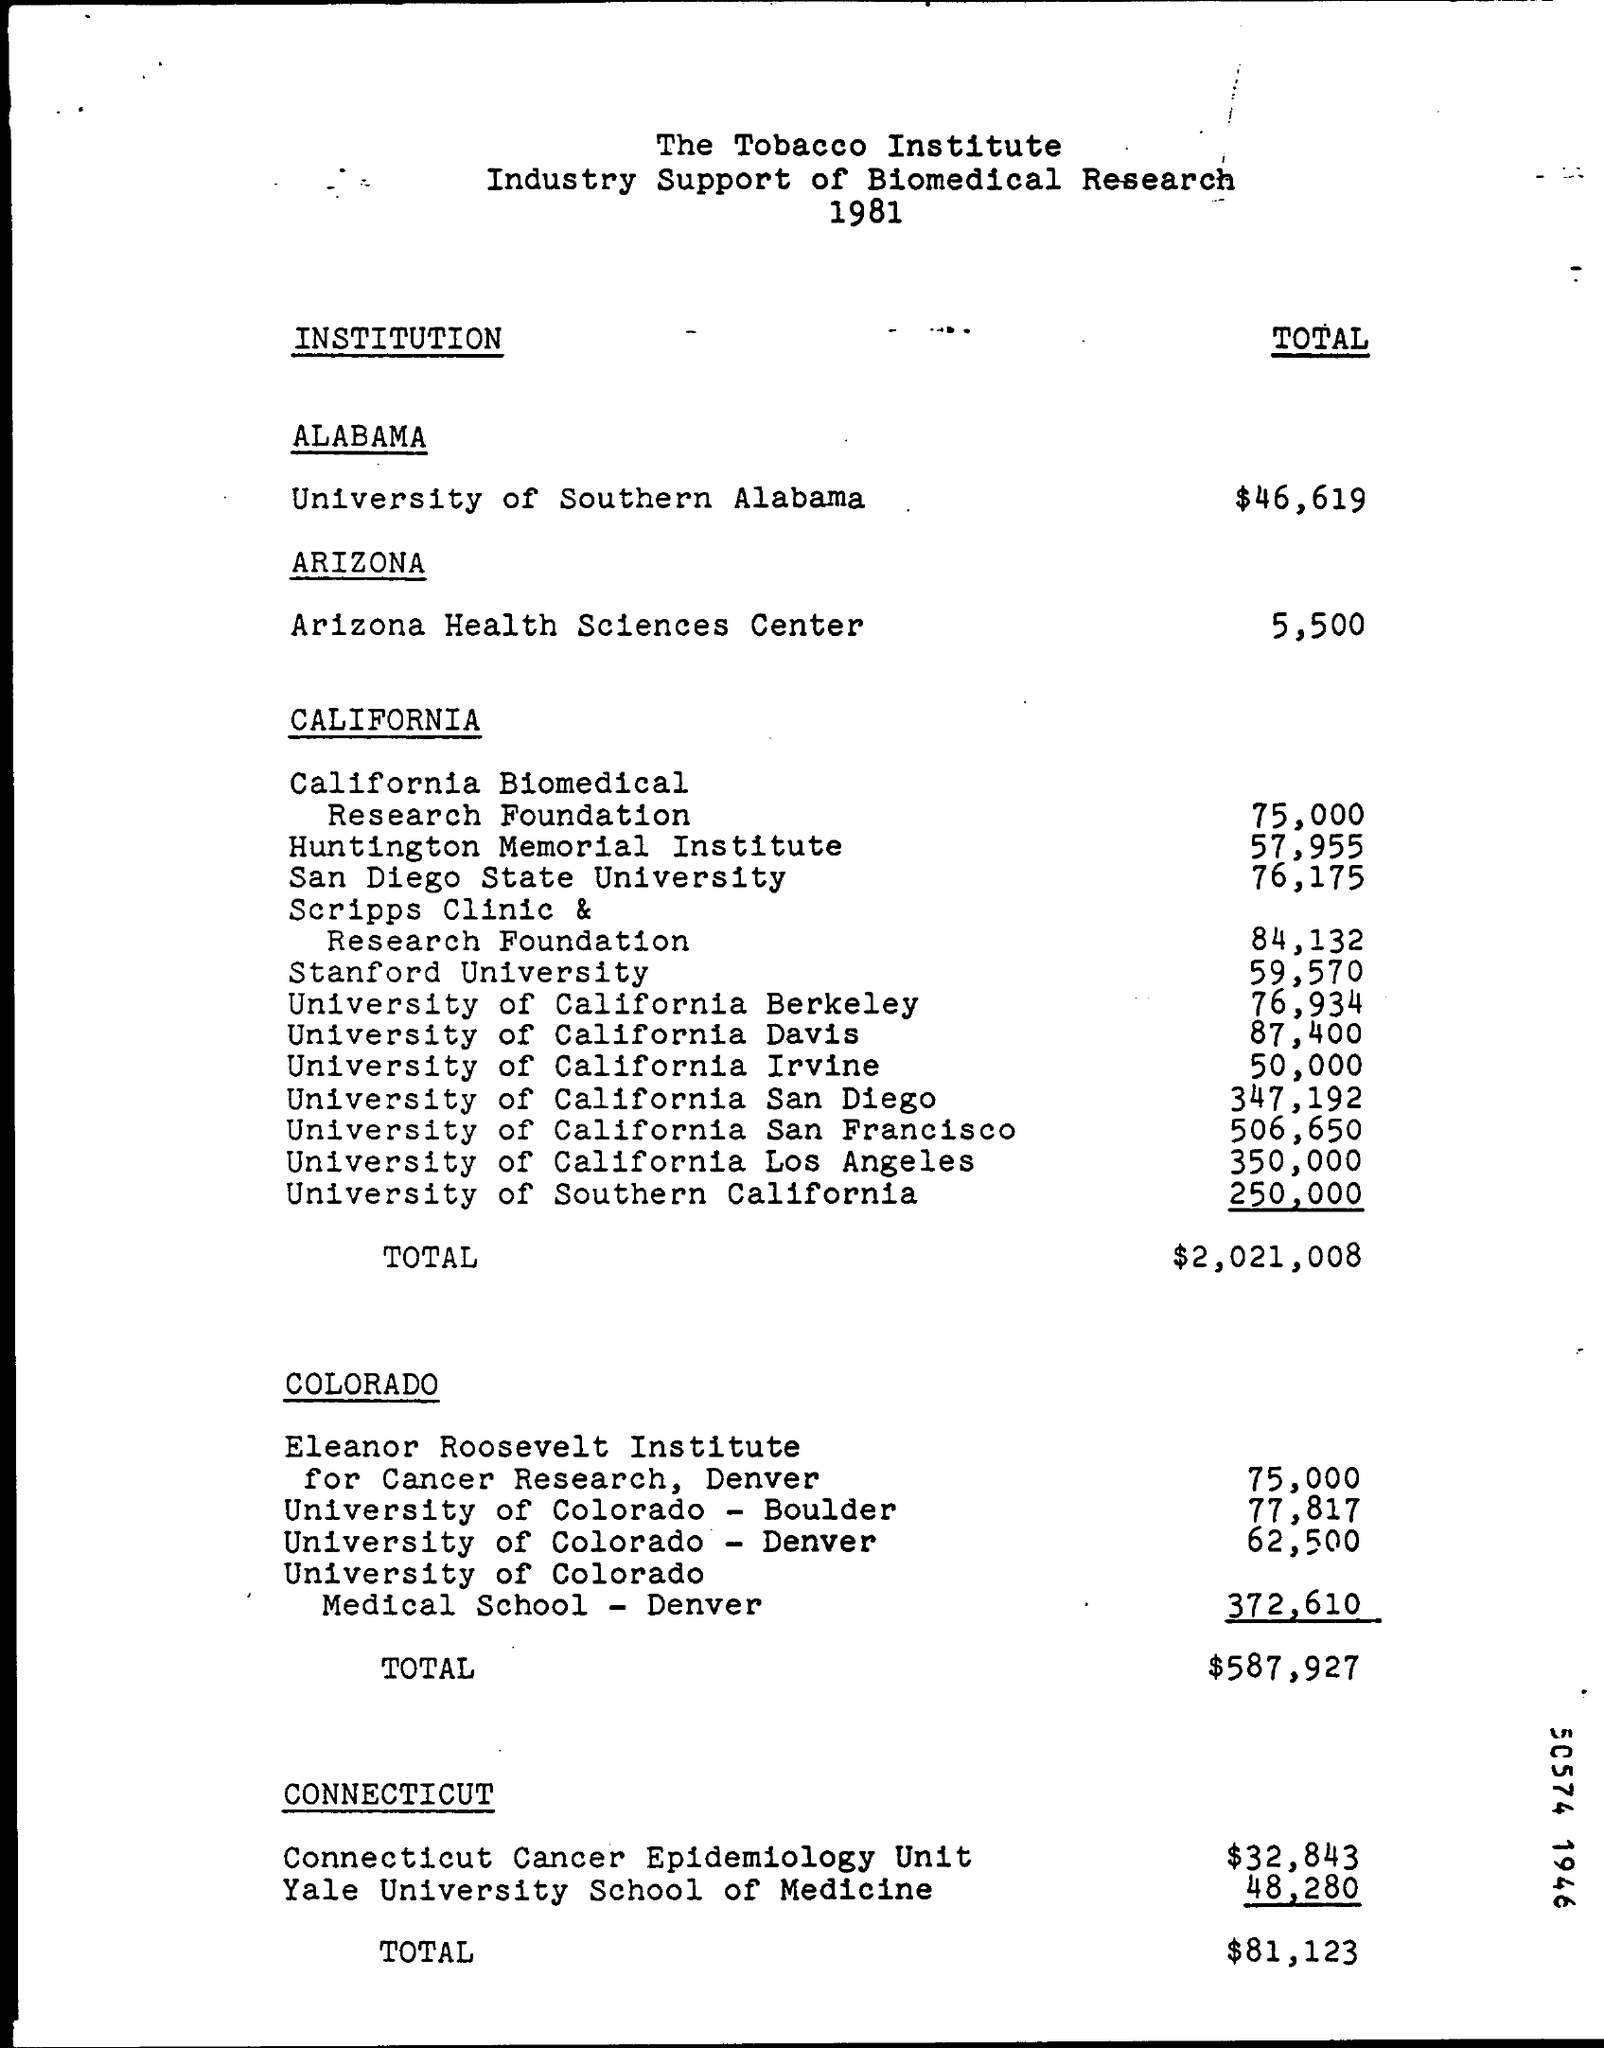Draw attention to some important aspects in this diagram. The Connecticut Cancer Epidemiology Unit was awarded a grant of $32,843. The total amount given for Arizona Health Sciences Center is $5,500. The California Biomedical has been granted 75,000 as a amount for . The University of Southern Alabama received a total of $46,619 for biomedical research. The amount given for the University of Colorado-Boulder is $77,817. 